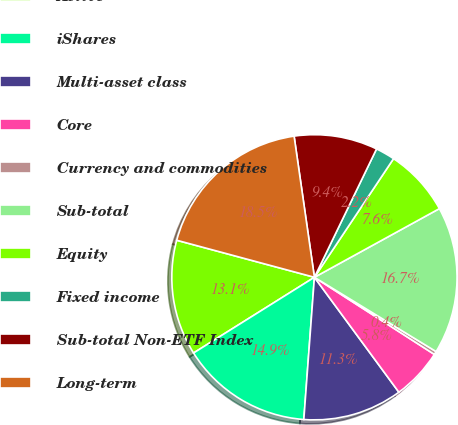<chart> <loc_0><loc_0><loc_500><loc_500><pie_chart><fcel>Active<fcel>iShares<fcel>Multi-asset class<fcel>Core<fcel>Currency and commodities<fcel>Sub-total<fcel>Equity<fcel>Fixed income<fcel>Sub-total Non-ETF Index<fcel>Long-term<nl><fcel>13.09%<fcel>14.91%<fcel>11.27%<fcel>5.82%<fcel>0.37%<fcel>16.72%<fcel>7.64%<fcel>2.19%<fcel>9.45%<fcel>18.54%<nl></chart> 